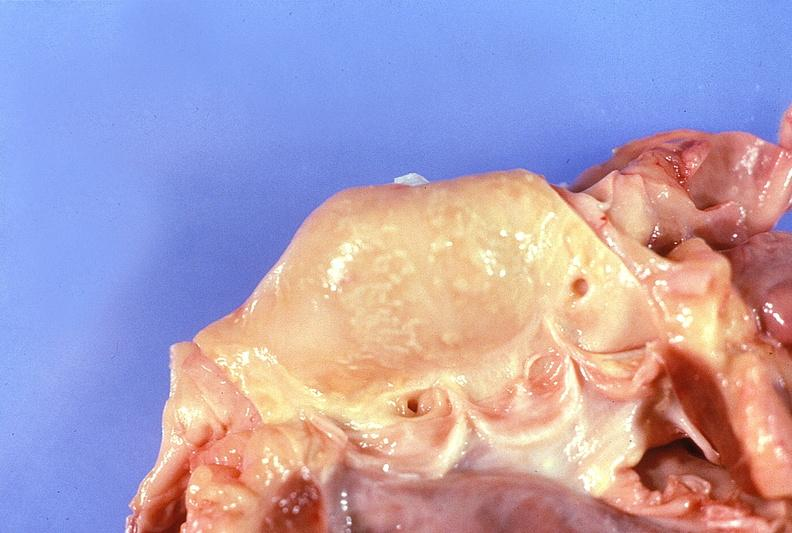does another fiber other frame show normal aortic valve?
Answer the question using a single word or phrase. No 